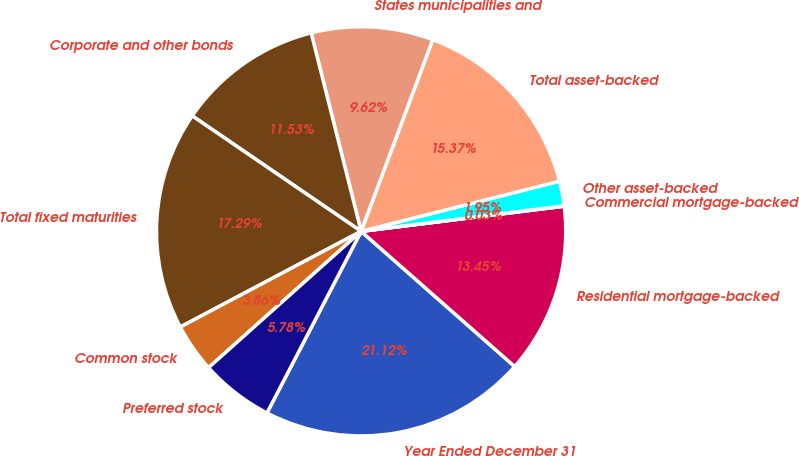Convert chart. <chart><loc_0><loc_0><loc_500><loc_500><pie_chart><fcel>Year Ended December 31<fcel>Residential mortgage-backed<fcel>Commercial mortgage-backed<fcel>Other asset-backed<fcel>Total asset-backed<fcel>States municipalities and<fcel>Corporate and other bonds<fcel>Total fixed maturities<fcel>Common stock<fcel>Preferred stock<nl><fcel>21.12%<fcel>13.45%<fcel>0.03%<fcel>1.95%<fcel>15.37%<fcel>9.62%<fcel>11.53%<fcel>17.29%<fcel>3.86%<fcel>5.78%<nl></chart> 